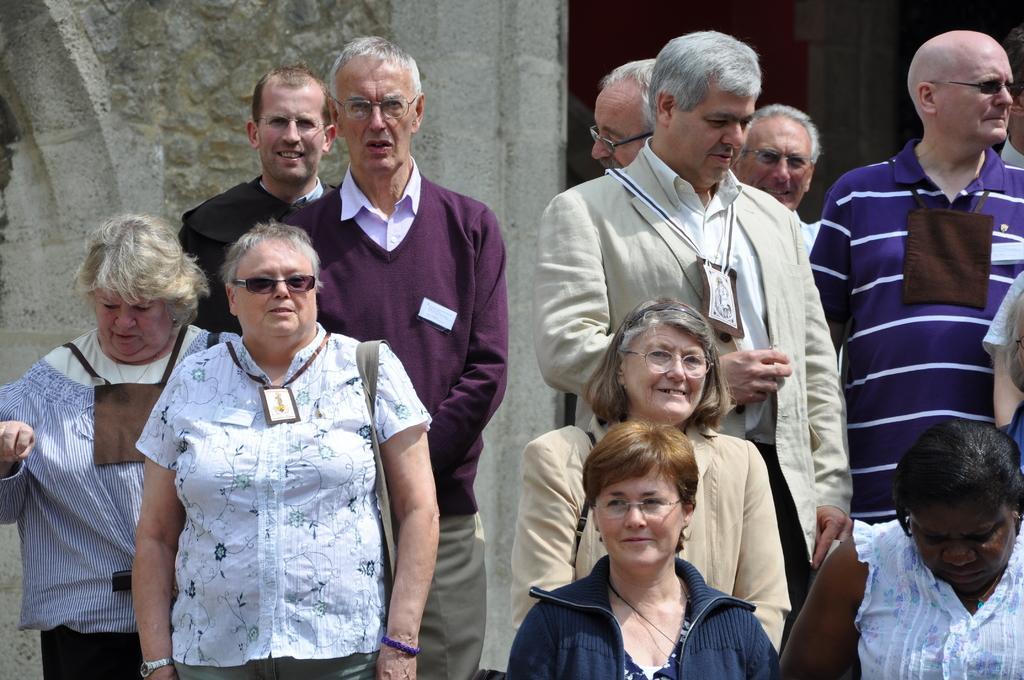In one or two sentences, can you explain what this image depicts? In this picture we can see a group of people are standing on the path and behind the people there is a wall. 